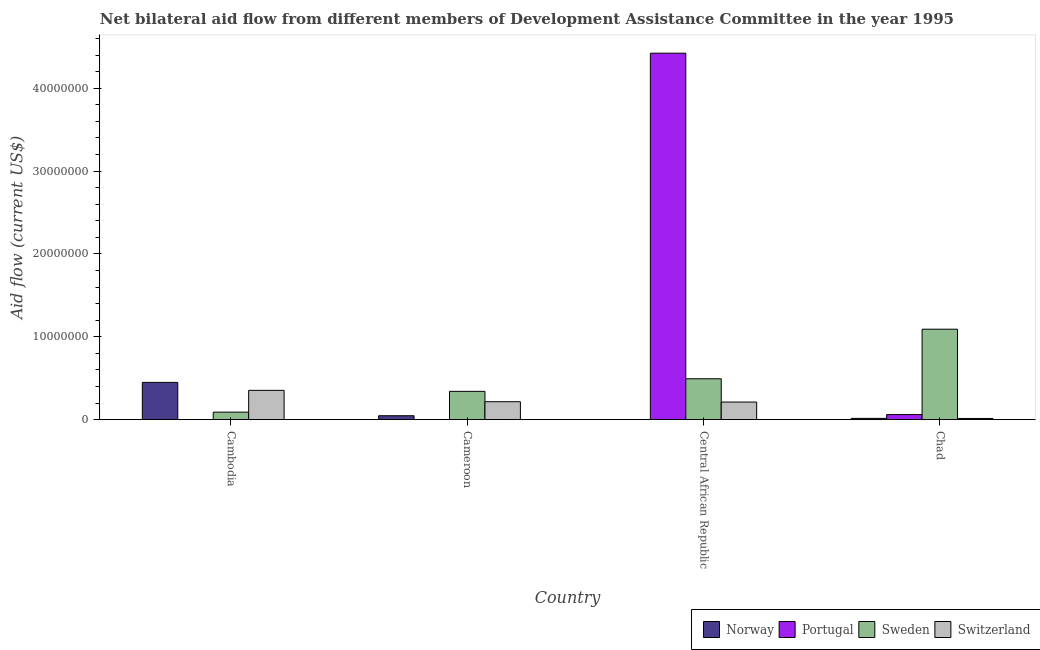How many groups of bars are there?
Give a very brief answer. 4. Are the number of bars per tick equal to the number of legend labels?
Offer a terse response. Yes. Are the number of bars on each tick of the X-axis equal?
Ensure brevity in your answer.  Yes. How many bars are there on the 2nd tick from the right?
Give a very brief answer. 4. What is the label of the 3rd group of bars from the left?
Make the answer very short. Central African Republic. In how many cases, is the number of bars for a given country not equal to the number of legend labels?
Ensure brevity in your answer.  0. What is the amount of aid given by switzerland in Central African Republic?
Give a very brief answer. 2.13e+06. Across all countries, what is the maximum amount of aid given by norway?
Make the answer very short. 4.50e+06. Across all countries, what is the minimum amount of aid given by switzerland?
Make the answer very short. 1.50e+05. In which country was the amount of aid given by switzerland maximum?
Provide a short and direct response. Cambodia. In which country was the amount of aid given by sweden minimum?
Provide a succinct answer. Cambodia. What is the total amount of aid given by switzerland in the graph?
Offer a very short reply. 7.99e+06. What is the difference between the amount of aid given by portugal in Cambodia and that in Chad?
Keep it short and to the point. -6.10e+05. What is the difference between the amount of aid given by norway in Chad and the amount of aid given by sweden in Central African Republic?
Your answer should be very brief. -4.78e+06. What is the average amount of aid given by portugal per country?
Keep it short and to the point. 1.12e+07. What is the difference between the amount of aid given by portugal and amount of aid given by switzerland in Cambodia?
Your answer should be compact. -3.53e+06. In how many countries, is the amount of aid given by portugal greater than 12000000 US$?
Your answer should be compact. 1. What is the ratio of the amount of aid given by portugal in Cambodia to that in Cameroon?
Provide a short and direct response. 0.5. Is the amount of aid given by portugal in Cambodia less than that in Chad?
Keep it short and to the point. Yes. Is the difference between the amount of aid given by norway in Cambodia and Cameroon greater than the difference between the amount of aid given by portugal in Cambodia and Cameroon?
Offer a very short reply. Yes. What is the difference between the highest and the second highest amount of aid given by portugal?
Offer a terse response. 4.36e+07. What is the difference between the highest and the lowest amount of aid given by switzerland?
Your answer should be compact. 3.39e+06. Is the sum of the amount of aid given by switzerland in Cameroon and Chad greater than the maximum amount of aid given by norway across all countries?
Give a very brief answer. No. Is it the case that in every country, the sum of the amount of aid given by sweden and amount of aid given by portugal is greater than the sum of amount of aid given by norway and amount of aid given by switzerland?
Your answer should be compact. Yes. What does the 2nd bar from the left in Chad represents?
Make the answer very short. Portugal. How many countries are there in the graph?
Your answer should be very brief. 4. What is the difference between two consecutive major ticks on the Y-axis?
Offer a terse response. 1.00e+07. Does the graph contain any zero values?
Your answer should be compact. No. How many legend labels are there?
Keep it short and to the point. 4. What is the title of the graph?
Ensure brevity in your answer.  Net bilateral aid flow from different members of Development Assistance Committee in the year 1995. What is the Aid flow (current US$) in Norway in Cambodia?
Your answer should be very brief. 4.50e+06. What is the Aid flow (current US$) of Portugal in Cambodia?
Offer a terse response. 10000. What is the Aid flow (current US$) in Sweden in Cambodia?
Keep it short and to the point. 9.10e+05. What is the Aid flow (current US$) in Switzerland in Cambodia?
Offer a terse response. 3.54e+06. What is the Aid flow (current US$) of Norway in Cameroon?
Provide a short and direct response. 4.80e+05. What is the Aid flow (current US$) of Portugal in Cameroon?
Offer a very short reply. 2.00e+04. What is the Aid flow (current US$) of Sweden in Cameroon?
Provide a succinct answer. 3.42e+06. What is the Aid flow (current US$) in Switzerland in Cameroon?
Keep it short and to the point. 2.17e+06. What is the Aid flow (current US$) of Norway in Central African Republic?
Ensure brevity in your answer.  10000. What is the Aid flow (current US$) in Portugal in Central African Republic?
Your answer should be compact. 4.42e+07. What is the Aid flow (current US$) in Sweden in Central African Republic?
Your answer should be very brief. 4.94e+06. What is the Aid flow (current US$) in Switzerland in Central African Republic?
Offer a very short reply. 2.13e+06. What is the Aid flow (current US$) of Norway in Chad?
Your answer should be compact. 1.60e+05. What is the Aid flow (current US$) in Portugal in Chad?
Your answer should be compact. 6.20e+05. What is the Aid flow (current US$) in Sweden in Chad?
Your response must be concise. 1.09e+07. What is the Aid flow (current US$) in Switzerland in Chad?
Your answer should be compact. 1.50e+05. Across all countries, what is the maximum Aid flow (current US$) in Norway?
Make the answer very short. 4.50e+06. Across all countries, what is the maximum Aid flow (current US$) in Portugal?
Keep it short and to the point. 4.42e+07. Across all countries, what is the maximum Aid flow (current US$) of Sweden?
Provide a short and direct response. 1.09e+07. Across all countries, what is the maximum Aid flow (current US$) of Switzerland?
Give a very brief answer. 3.54e+06. Across all countries, what is the minimum Aid flow (current US$) in Norway?
Give a very brief answer. 10000. Across all countries, what is the minimum Aid flow (current US$) in Sweden?
Offer a very short reply. 9.10e+05. What is the total Aid flow (current US$) in Norway in the graph?
Provide a succinct answer. 5.15e+06. What is the total Aid flow (current US$) of Portugal in the graph?
Ensure brevity in your answer.  4.49e+07. What is the total Aid flow (current US$) of Sweden in the graph?
Provide a short and direct response. 2.02e+07. What is the total Aid flow (current US$) in Switzerland in the graph?
Your response must be concise. 7.99e+06. What is the difference between the Aid flow (current US$) in Norway in Cambodia and that in Cameroon?
Your answer should be compact. 4.02e+06. What is the difference between the Aid flow (current US$) of Portugal in Cambodia and that in Cameroon?
Keep it short and to the point. -10000. What is the difference between the Aid flow (current US$) of Sweden in Cambodia and that in Cameroon?
Provide a short and direct response. -2.51e+06. What is the difference between the Aid flow (current US$) of Switzerland in Cambodia and that in Cameroon?
Provide a short and direct response. 1.37e+06. What is the difference between the Aid flow (current US$) in Norway in Cambodia and that in Central African Republic?
Your answer should be compact. 4.49e+06. What is the difference between the Aid flow (current US$) of Portugal in Cambodia and that in Central African Republic?
Offer a very short reply. -4.42e+07. What is the difference between the Aid flow (current US$) of Sweden in Cambodia and that in Central African Republic?
Your answer should be very brief. -4.03e+06. What is the difference between the Aid flow (current US$) of Switzerland in Cambodia and that in Central African Republic?
Your answer should be very brief. 1.41e+06. What is the difference between the Aid flow (current US$) in Norway in Cambodia and that in Chad?
Provide a short and direct response. 4.34e+06. What is the difference between the Aid flow (current US$) of Portugal in Cambodia and that in Chad?
Offer a very short reply. -6.10e+05. What is the difference between the Aid flow (current US$) in Sweden in Cambodia and that in Chad?
Make the answer very short. -1.00e+07. What is the difference between the Aid flow (current US$) in Switzerland in Cambodia and that in Chad?
Your answer should be compact. 3.39e+06. What is the difference between the Aid flow (current US$) of Portugal in Cameroon and that in Central African Republic?
Your response must be concise. -4.42e+07. What is the difference between the Aid flow (current US$) in Sweden in Cameroon and that in Central African Republic?
Your answer should be compact. -1.52e+06. What is the difference between the Aid flow (current US$) of Switzerland in Cameroon and that in Central African Republic?
Keep it short and to the point. 4.00e+04. What is the difference between the Aid flow (current US$) of Norway in Cameroon and that in Chad?
Your answer should be compact. 3.20e+05. What is the difference between the Aid flow (current US$) of Portugal in Cameroon and that in Chad?
Offer a very short reply. -6.00e+05. What is the difference between the Aid flow (current US$) of Sweden in Cameroon and that in Chad?
Keep it short and to the point. -7.50e+06. What is the difference between the Aid flow (current US$) in Switzerland in Cameroon and that in Chad?
Make the answer very short. 2.02e+06. What is the difference between the Aid flow (current US$) in Portugal in Central African Republic and that in Chad?
Provide a succinct answer. 4.36e+07. What is the difference between the Aid flow (current US$) in Sweden in Central African Republic and that in Chad?
Your answer should be very brief. -5.98e+06. What is the difference between the Aid flow (current US$) of Switzerland in Central African Republic and that in Chad?
Make the answer very short. 1.98e+06. What is the difference between the Aid flow (current US$) in Norway in Cambodia and the Aid flow (current US$) in Portugal in Cameroon?
Your answer should be compact. 4.48e+06. What is the difference between the Aid flow (current US$) in Norway in Cambodia and the Aid flow (current US$) in Sweden in Cameroon?
Your answer should be very brief. 1.08e+06. What is the difference between the Aid flow (current US$) in Norway in Cambodia and the Aid flow (current US$) in Switzerland in Cameroon?
Your answer should be compact. 2.33e+06. What is the difference between the Aid flow (current US$) in Portugal in Cambodia and the Aid flow (current US$) in Sweden in Cameroon?
Keep it short and to the point. -3.41e+06. What is the difference between the Aid flow (current US$) of Portugal in Cambodia and the Aid flow (current US$) of Switzerland in Cameroon?
Your answer should be very brief. -2.16e+06. What is the difference between the Aid flow (current US$) of Sweden in Cambodia and the Aid flow (current US$) of Switzerland in Cameroon?
Provide a short and direct response. -1.26e+06. What is the difference between the Aid flow (current US$) of Norway in Cambodia and the Aid flow (current US$) of Portugal in Central African Republic?
Keep it short and to the point. -3.97e+07. What is the difference between the Aid flow (current US$) of Norway in Cambodia and the Aid flow (current US$) of Sweden in Central African Republic?
Offer a very short reply. -4.40e+05. What is the difference between the Aid flow (current US$) in Norway in Cambodia and the Aid flow (current US$) in Switzerland in Central African Republic?
Provide a short and direct response. 2.37e+06. What is the difference between the Aid flow (current US$) of Portugal in Cambodia and the Aid flow (current US$) of Sweden in Central African Republic?
Provide a succinct answer. -4.93e+06. What is the difference between the Aid flow (current US$) of Portugal in Cambodia and the Aid flow (current US$) of Switzerland in Central African Republic?
Provide a short and direct response. -2.12e+06. What is the difference between the Aid flow (current US$) in Sweden in Cambodia and the Aid flow (current US$) in Switzerland in Central African Republic?
Provide a short and direct response. -1.22e+06. What is the difference between the Aid flow (current US$) of Norway in Cambodia and the Aid flow (current US$) of Portugal in Chad?
Provide a short and direct response. 3.88e+06. What is the difference between the Aid flow (current US$) of Norway in Cambodia and the Aid flow (current US$) of Sweden in Chad?
Provide a short and direct response. -6.42e+06. What is the difference between the Aid flow (current US$) of Norway in Cambodia and the Aid flow (current US$) of Switzerland in Chad?
Make the answer very short. 4.35e+06. What is the difference between the Aid flow (current US$) of Portugal in Cambodia and the Aid flow (current US$) of Sweden in Chad?
Give a very brief answer. -1.09e+07. What is the difference between the Aid flow (current US$) in Portugal in Cambodia and the Aid flow (current US$) in Switzerland in Chad?
Make the answer very short. -1.40e+05. What is the difference between the Aid flow (current US$) of Sweden in Cambodia and the Aid flow (current US$) of Switzerland in Chad?
Your response must be concise. 7.60e+05. What is the difference between the Aid flow (current US$) of Norway in Cameroon and the Aid flow (current US$) of Portugal in Central African Republic?
Provide a succinct answer. -4.37e+07. What is the difference between the Aid flow (current US$) of Norway in Cameroon and the Aid flow (current US$) of Sweden in Central African Republic?
Your answer should be very brief. -4.46e+06. What is the difference between the Aid flow (current US$) in Norway in Cameroon and the Aid flow (current US$) in Switzerland in Central African Republic?
Keep it short and to the point. -1.65e+06. What is the difference between the Aid flow (current US$) of Portugal in Cameroon and the Aid flow (current US$) of Sweden in Central African Republic?
Make the answer very short. -4.92e+06. What is the difference between the Aid flow (current US$) in Portugal in Cameroon and the Aid flow (current US$) in Switzerland in Central African Republic?
Your answer should be compact. -2.11e+06. What is the difference between the Aid flow (current US$) in Sweden in Cameroon and the Aid flow (current US$) in Switzerland in Central African Republic?
Offer a very short reply. 1.29e+06. What is the difference between the Aid flow (current US$) in Norway in Cameroon and the Aid flow (current US$) in Portugal in Chad?
Your answer should be very brief. -1.40e+05. What is the difference between the Aid flow (current US$) in Norway in Cameroon and the Aid flow (current US$) in Sweden in Chad?
Your answer should be very brief. -1.04e+07. What is the difference between the Aid flow (current US$) in Norway in Cameroon and the Aid flow (current US$) in Switzerland in Chad?
Offer a very short reply. 3.30e+05. What is the difference between the Aid flow (current US$) of Portugal in Cameroon and the Aid flow (current US$) of Sweden in Chad?
Provide a succinct answer. -1.09e+07. What is the difference between the Aid flow (current US$) of Portugal in Cameroon and the Aid flow (current US$) of Switzerland in Chad?
Give a very brief answer. -1.30e+05. What is the difference between the Aid flow (current US$) in Sweden in Cameroon and the Aid flow (current US$) in Switzerland in Chad?
Your response must be concise. 3.27e+06. What is the difference between the Aid flow (current US$) of Norway in Central African Republic and the Aid flow (current US$) of Portugal in Chad?
Provide a short and direct response. -6.10e+05. What is the difference between the Aid flow (current US$) in Norway in Central African Republic and the Aid flow (current US$) in Sweden in Chad?
Your answer should be compact. -1.09e+07. What is the difference between the Aid flow (current US$) in Norway in Central African Republic and the Aid flow (current US$) in Switzerland in Chad?
Provide a succinct answer. -1.40e+05. What is the difference between the Aid flow (current US$) in Portugal in Central African Republic and the Aid flow (current US$) in Sweden in Chad?
Make the answer very short. 3.33e+07. What is the difference between the Aid flow (current US$) in Portugal in Central African Republic and the Aid flow (current US$) in Switzerland in Chad?
Offer a terse response. 4.41e+07. What is the difference between the Aid flow (current US$) of Sweden in Central African Republic and the Aid flow (current US$) of Switzerland in Chad?
Your answer should be very brief. 4.79e+06. What is the average Aid flow (current US$) in Norway per country?
Your response must be concise. 1.29e+06. What is the average Aid flow (current US$) in Portugal per country?
Make the answer very short. 1.12e+07. What is the average Aid flow (current US$) in Sweden per country?
Ensure brevity in your answer.  5.05e+06. What is the average Aid flow (current US$) of Switzerland per country?
Ensure brevity in your answer.  2.00e+06. What is the difference between the Aid flow (current US$) of Norway and Aid flow (current US$) of Portugal in Cambodia?
Provide a succinct answer. 4.49e+06. What is the difference between the Aid flow (current US$) in Norway and Aid flow (current US$) in Sweden in Cambodia?
Your response must be concise. 3.59e+06. What is the difference between the Aid flow (current US$) in Norway and Aid flow (current US$) in Switzerland in Cambodia?
Offer a very short reply. 9.60e+05. What is the difference between the Aid flow (current US$) of Portugal and Aid flow (current US$) of Sweden in Cambodia?
Offer a very short reply. -9.00e+05. What is the difference between the Aid flow (current US$) in Portugal and Aid flow (current US$) in Switzerland in Cambodia?
Give a very brief answer. -3.53e+06. What is the difference between the Aid flow (current US$) in Sweden and Aid flow (current US$) in Switzerland in Cambodia?
Your response must be concise. -2.63e+06. What is the difference between the Aid flow (current US$) in Norway and Aid flow (current US$) in Portugal in Cameroon?
Your answer should be very brief. 4.60e+05. What is the difference between the Aid flow (current US$) of Norway and Aid flow (current US$) of Sweden in Cameroon?
Give a very brief answer. -2.94e+06. What is the difference between the Aid flow (current US$) in Norway and Aid flow (current US$) in Switzerland in Cameroon?
Offer a terse response. -1.69e+06. What is the difference between the Aid flow (current US$) of Portugal and Aid flow (current US$) of Sweden in Cameroon?
Give a very brief answer. -3.40e+06. What is the difference between the Aid flow (current US$) of Portugal and Aid flow (current US$) of Switzerland in Cameroon?
Offer a terse response. -2.15e+06. What is the difference between the Aid flow (current US$) of Sweden and Aid flow (current US$) of Switzerland in Cameroon?
Offer a very short reply. 1.25e+06. What is the difference between the Aid flow (current US$) in Norway and Aid flow (current US$) in Portugal in Central African Republic?
Make the answer very short. -4.42e+07. What is the difference between the Aid flow (current US$) of Norway and Aid flow (current US$) of Sweden in Central African Republic?
Provide a short and direct response. -4.93e+06. What is the difference between the Aid flow (current US$) of Norway and Aid flow (current US$) of Switzerland in Central African Republic?
Your response must be concise. -2.12e+06. What is the difference between the Aid flow (current US$) of Portugal and Aid flow (current US$) of Sweden in Central African Republic?
Make the answer very short. 3.93e+07. What is the difference between the Aid flow (current US$) of Portugal and Aid flow (current US$) of Switzerland in Central African Republic?
Your response must be concise. 4.21e+07. What is the difference between the Aid flow (current US$) of Sweden and Aid flow (current US$) of Switzerland in Central African Republic?
Ensure brevity in your answer.  2.81e+06. What is the difference between the Aid flow (current US$) of Norway and Aid flow (current US$) of Portugal in Chad?
Provide a succinct answer. -4.60e+05. What is the difference between the Aid flow (current US$) of Norway and Aid flow (current US$) of Sweden in Chad?
Keep it short and to the point. -1.08e+07. What is the difference between the Aid flow (current US$) in Norway and Aid flow (current US$) in Switzerland in Chad?
Your answer should be very brief. 10000. What is the difference between the Aid flow (current US$) of Portugal and Aid flow (current US$) of Sweden in Chad?
Offer a very short reply. -1.03e+07. What is the difference between the Aid flow (current US$) in Sweden and Aid flow (current US$) in Switzerland in Chad?
Make the answer very short. 1.08e+07. What is the ratio of the Aid flow (current US$) in Norway in Cambodia to that in Cameroon?
Your answer should be compact. 9.38. What is the ratio of the Aid flow (current US$) in Portugal in Cambodia to that in Cameroon?
Make the answer very short. 0.5. What is the ratio of the Aid flow (current US$) of Sweden in Cambodia to that in Cameroon?
Provide a short and direct response. 0.27. What is the ratio of the Aid flow (current US$) of Switzerland in Cambodia to that in Cameroon?
Provide a succinct answer. 1.63. What is the ratio of the Aid flow (current US$) in Norway in Cambodia to that in Central African Republic?
Provide a succinct answer. 450. What is the ratio of the Aid flow (current US$) of Portugal in Cambodia to that in Central African Republic?
Offer a terse response. 0. What is the ratio of the Aid flow (current US$) in Sweden in Cambodia to that in Central African Republic?
Ensure brevity in your answer.  0.18. What is the ratio of the Aid flow (current US$) of Switzerland in Cambodia to that in Central African Republic?
Your response must be concise. 1.66. What is the ratio of the Aid flow (current US$) in Norway in Cambodia to that in Chad?
Your answer should be compact. 28.12. What is the ratio of the Aid flow (current US$) of Portugal in Cambodia to that in Chad?
Provide a short and direct response. 0.02. What is the ratio of the Aid flow (current US$) in Sweden in Cambodia to that in Chad?
Your response must be concise. 0.08. What is the ratio of the Aid flow (current US$) of Switzerland in Cambodia to that in Chad?
Your answer should be compact. 23.6. What is the ratio of the Aid flow (current US$) of Norway in Cameroon to that in Central African Republic?
Offer a terse response. 48. What is the ratio of the Aid flow (current US$) in Sweden in Cameroon to that in Central African Republic?
Keep it short and to the point. 0.69. What is the ratio of the Aid flow (current US$) in Switzerland in Cameroon to that in Central African Republic?
Your response must be concise. 1.02. What is the ratio of the Aid flow (current US$) of Norway in Cameroon to that in Chad?
Your response must be concise. 3. What is the ratio of the Aid flow (current US$) in Portugal in Cameroon to that in Chad?
Give a very brief answer. 0.03. What is the ratio of the Aid flow (current US$) in Sweden in Cameroon to that in Chad?
Offer a terse response. 0.31. What is the ratio of the Aid flow (current US$) in Switzerland in Cameroon to that in Chad?
Offer a very short reply. 14.47. What is the ratio of the Aid flow (current US$) of Norway in Central African Republic to that in Chad?
Your response must be concise. 0.06. What is the ratio of the Aid flow (current US$) in Portugal in Central African Republic to that in Chad?
Offer a very short reply. 71.32. What is the ratio of the Aid flow (current US$) in Sweden in Central African Republic to that in Chad?
Ensure brevity in your answer.  0.45. What is the difference between the highest and the second highest Aid flow (current US$) in Norway?
Provide a succinct answer. 4.02e+06. What is the difference between the highest and the second highest Aid flow (current US$) in Portugal?
Your answer should be very brief. 4.36e+07. What is the difference between the highest and the second highest Aid flow (current US$) in Sweden?
Offer a terse response. 5.98e+06. What is the difference between the highest and the second highest Aid flow (current US$) of Switzerland?
Keep it short and to the point. 1.37e+06. What is the difference between the highest and the lowest Aid flow (current US$) of Norway?
Ensure brevity in your answer.  4.49e+06. What is the difference between the highest and the lowest Aid flow (current US$) of Portugal?
Offer a terse response. 4.42e+07. What is the difference between the highest and the lowest Aid flow (current US$) of Sweden?
Provide a succinct answer. 1.00e+07. What is the difference between the highest and the lowest Aid flow (current US$) of Switzerland?
Your response must be concise. 3.39e+06. 